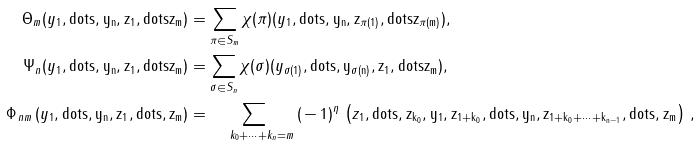<formula> <loc_0><loc_0><loc_500><loc_500>\Theta _ { m } ( y _ { 1 } , \tt d o t s , y _ { n } , z _ { 1 } , \tt d o t s z _ { m } ) & = \sum _ { \pi \in S _ { m } } \chi ( \pi ) ( y _ { 1 } , \tt d o t s , y _ { n } , z _ { \pi ( 1 ) } , \tt d o t s z _ { \pi ( m ) } ) , \\ \Psi _ { n } ( y _ { 1 } , \tt d o t s , y _ { n } , z _ { 1 } , \tt d o t s z _ { m } ) & = \sum _ { \sigma \in S _ { n } } \chi ( \sigma ) ( y _ { \sigma ( 1 ) } , \tt d o t s , y _ { \sigma ( n ) } , z _ { 1 } , \tt d o t s z _ { m } ) , \\ \Phi _ { \, n m \, } ( y _ { 1 } , \tt d o t s , y _ { n } , z _ { 1 } , \tt d o t s , z _ { m } ) & = \, \sum _ { \quad k _ { 0 } + \dots + k _ { n } = m } \, ( \, - \, 1 ) ^ { \eta } \, \left ( z _ { 1 } , \tt d o t s , z _ { k _ { 0 } } , y _ { 1 } , z _ { 1 + k _ { 0 } } , \tt d o t s , y _ { n } , z _ { 1 + k _ { 0 } + \dots + k _ { n - 1 } } , \tt d o t s , z _ { m } \right ) \, ,</formula> 